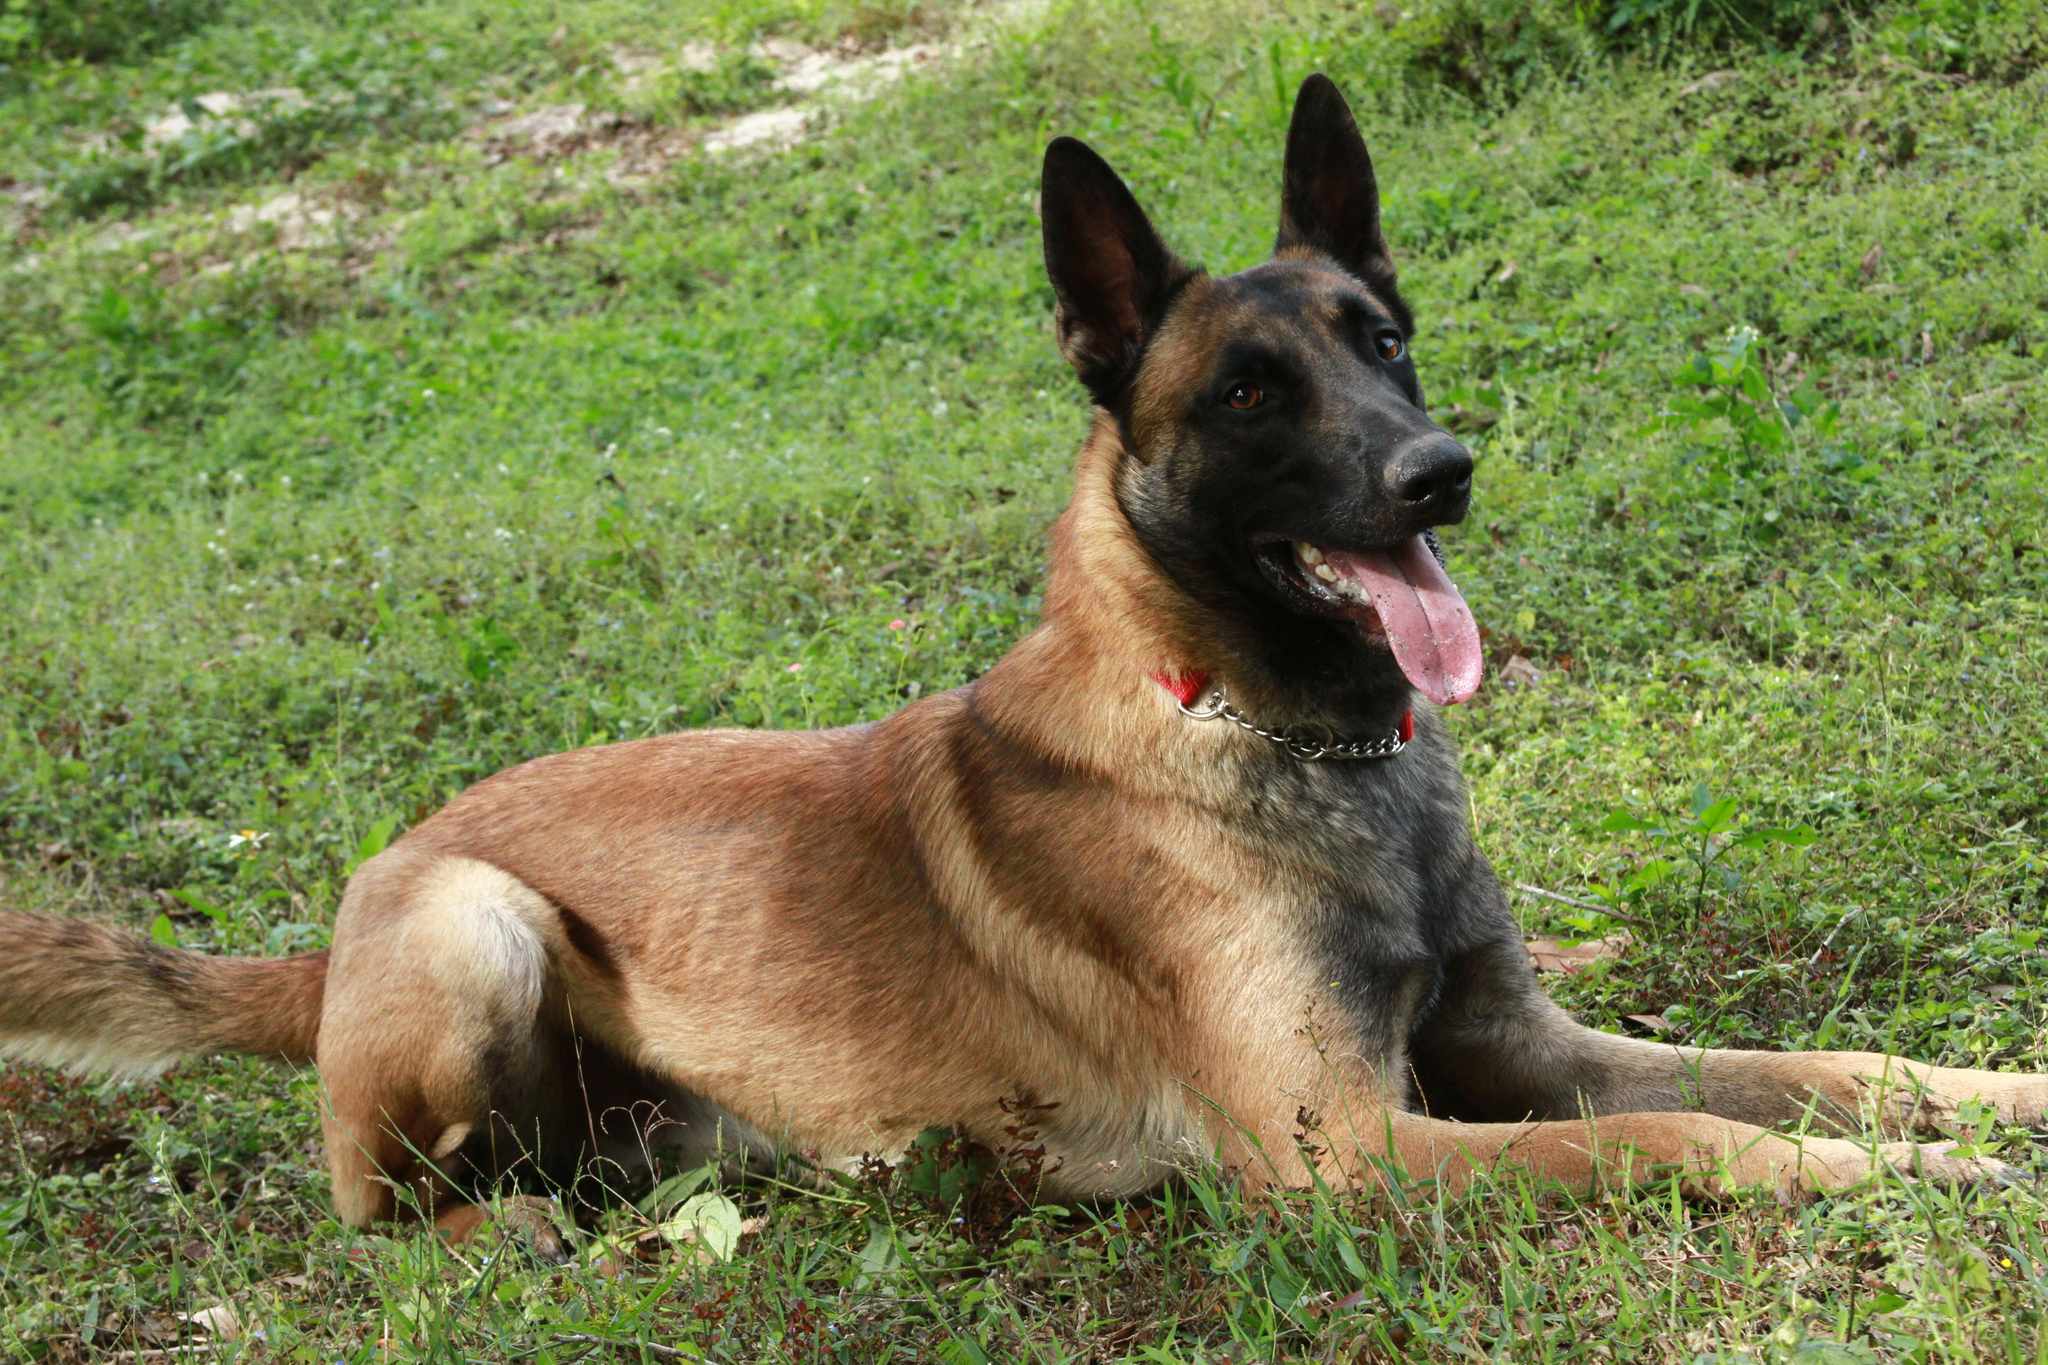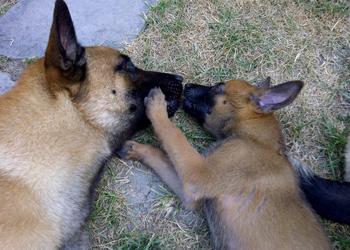The first image is the image on the left, the second image is the image on the right. Evaluate the accuracy of this statement regarding the images: "There are three adult German Shepherds sitting in the grass.". Is it true? Answer yes or no. No. The first image is the image on the left, the second image is the image on the right. Evaluate the accuracy of this statement regarding the images: "There is one lone brown german shepherd sitting in the grass.". Is it true? Answer yes or no. Yes. 